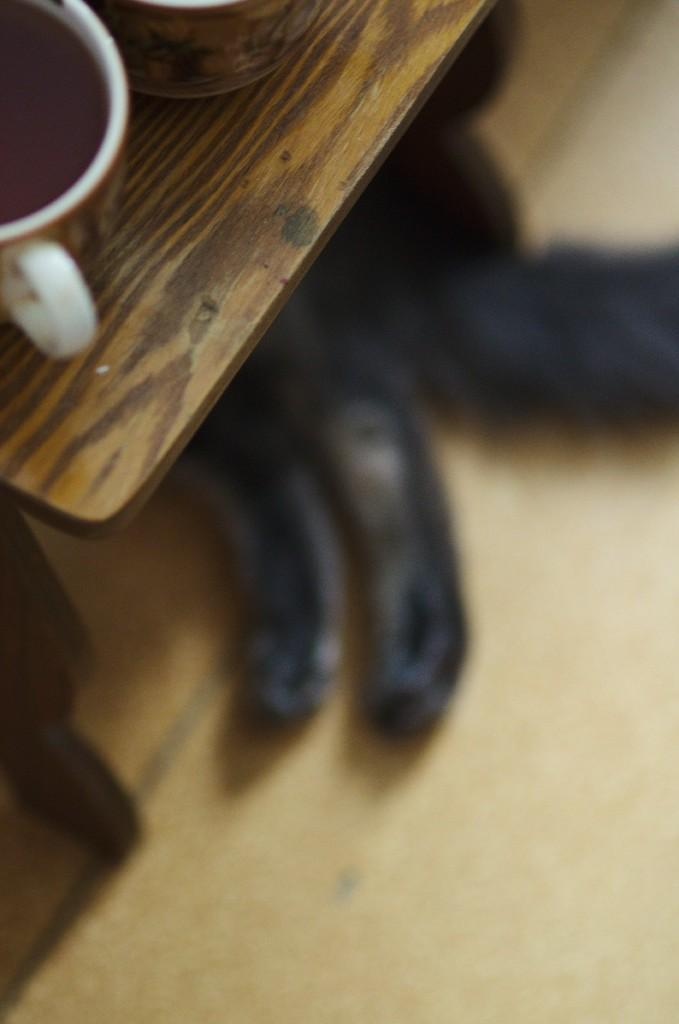What piece of furniture is visible in the image? There is a table in the image. What is placed on the table? A cup is present on the table. What animal can be seen lying on the floor? There is a cat lying on the floor. Where was the image taken? The image was taken inside a house. What type of frame is the cat using to fly a kite in the image? There is no frame or kite present in the image; it features a table, a cup, and a cat lying on the floor inside a house. What is the plot of the story unfolding in the image? There is no story or plot depicted in the image; it is a simple scene of a table, a cup, a cat, and a house interior. 